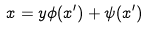<formula> <loc_0><loc_0><loc_500><loc_500>x = y \phi ( x ^ { \prime } ) + \psi ( x ^ { \prime } )</formula> 